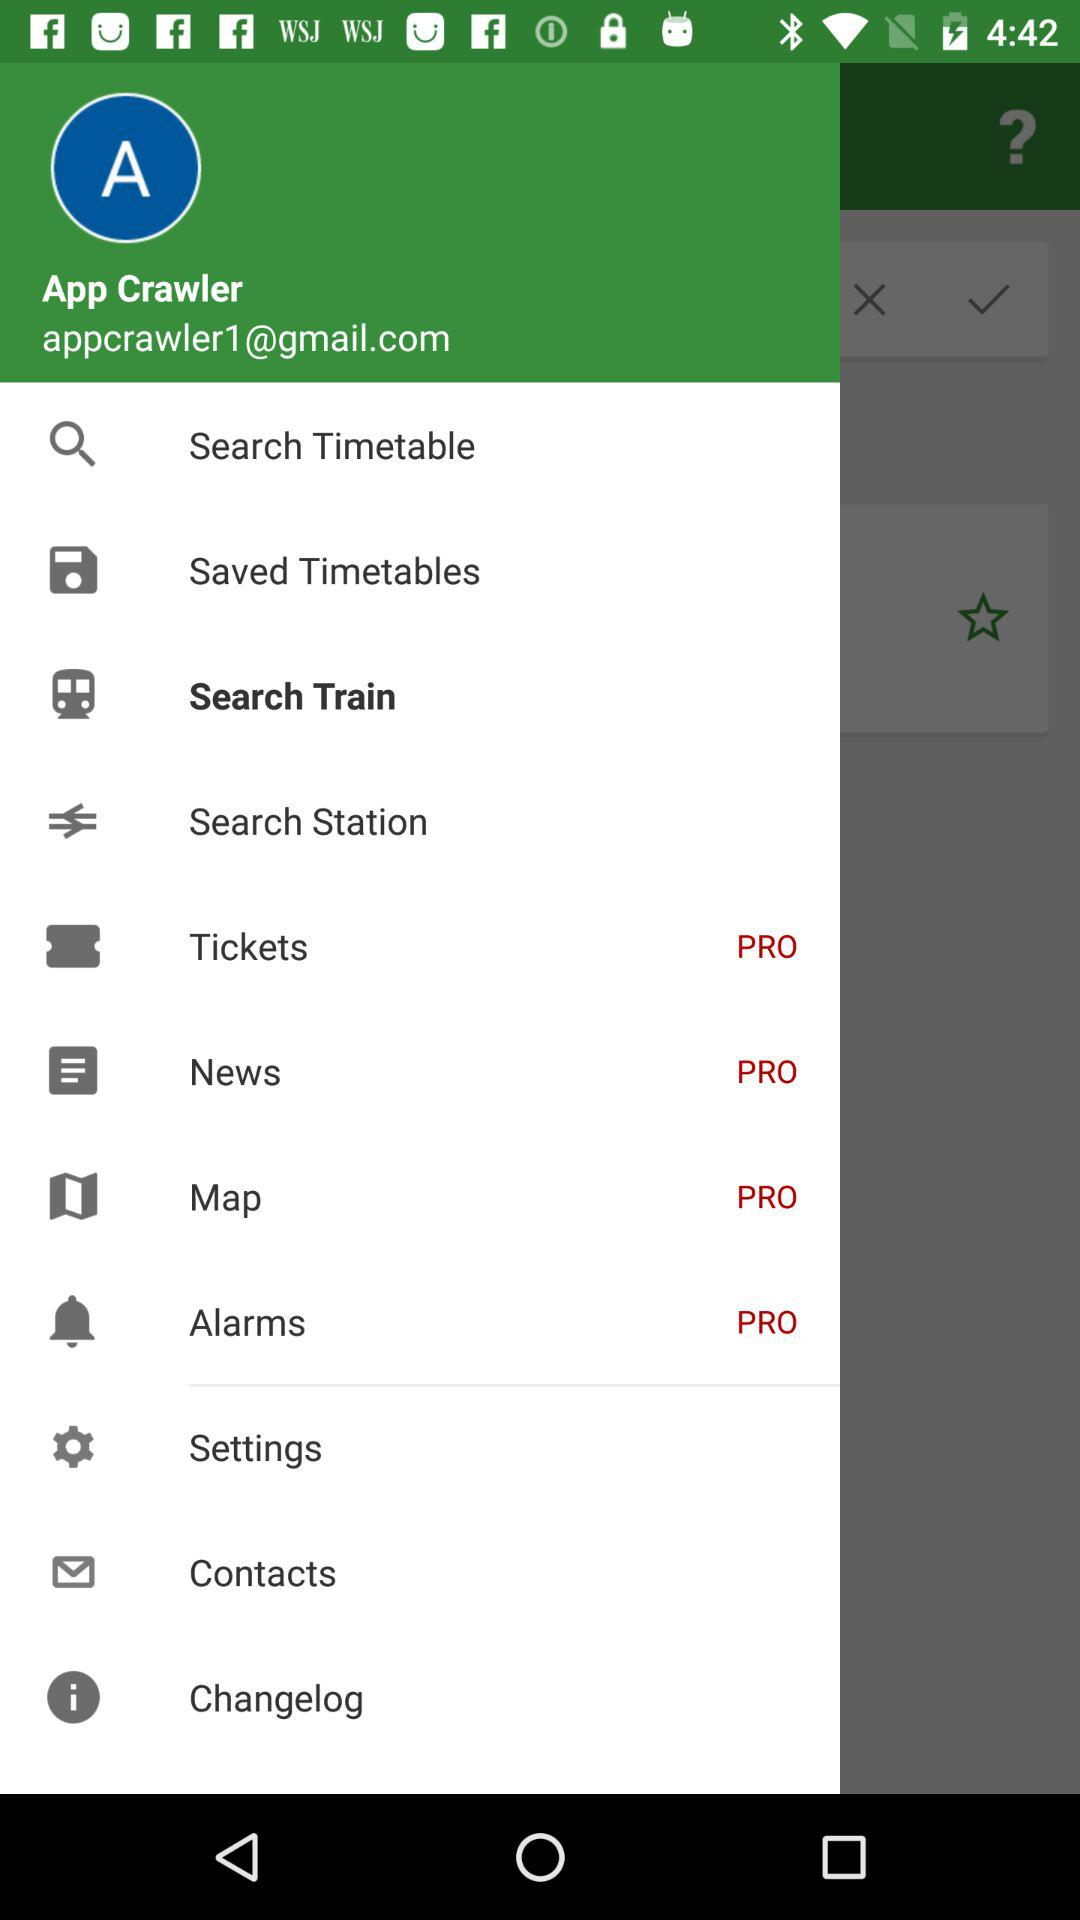What is the email address of the App Crawler? The email address of the App Crawler is appcrawler1@gmail.com. 